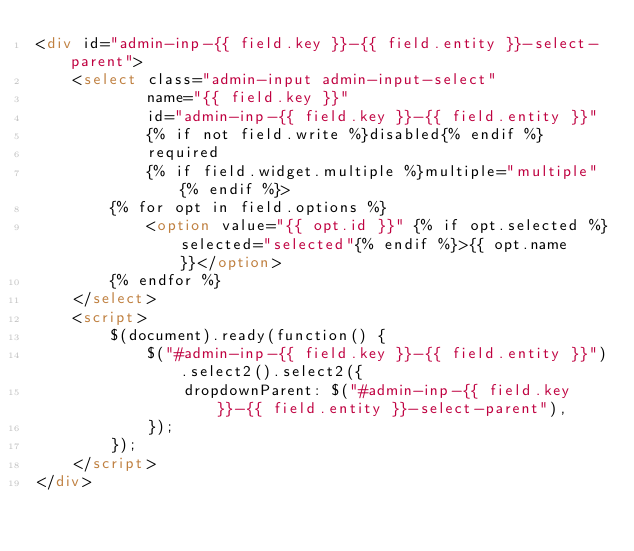<code> <loc_0><loc_0><loc_500><loc_500><_HTML_><div id="admin-inp-{{ field.key }}-{{ field.entity }}-select-parent">
    <select class="admin-input admin-input-select"
            name="{{ field.key }}"
            id="admin-inp-{{ field.key }}-{{ field.entity }}"
            {% if not field.write %}disabled{% endif %}
            required
            {% if field.widget.multiple %}multiple="multiple"{% endif %}>
        {% for opt in field.options %}
            <option value="{{ opt.id }}" {% if opt.selected %}selected="selected"{% endif %}>{{ opt.name }}</option>
        {% endfor %}
    </select>
    <script>
        $(document).ready(function() {
            $("#admin-inp-{{ field.key }}-{{ field.entity }}").select2().select2({
                dropdownParent: $("#admin-inp-{{ field.key }}-{{ field.entity }}-select-parent"),
            });
        });
    </script>
</div>
</code> 